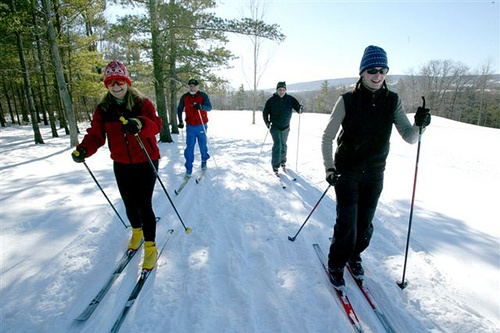Describe the objects in this image and their specific colors. I can see people in black, gray, blue, and white tones, people in black, maroon, gray, and olive tones, people in black, maroon, blue, and navy tones, people in black, teal, gray, and darkblue tones, and skis in black, blue, and gray tones in this image. 